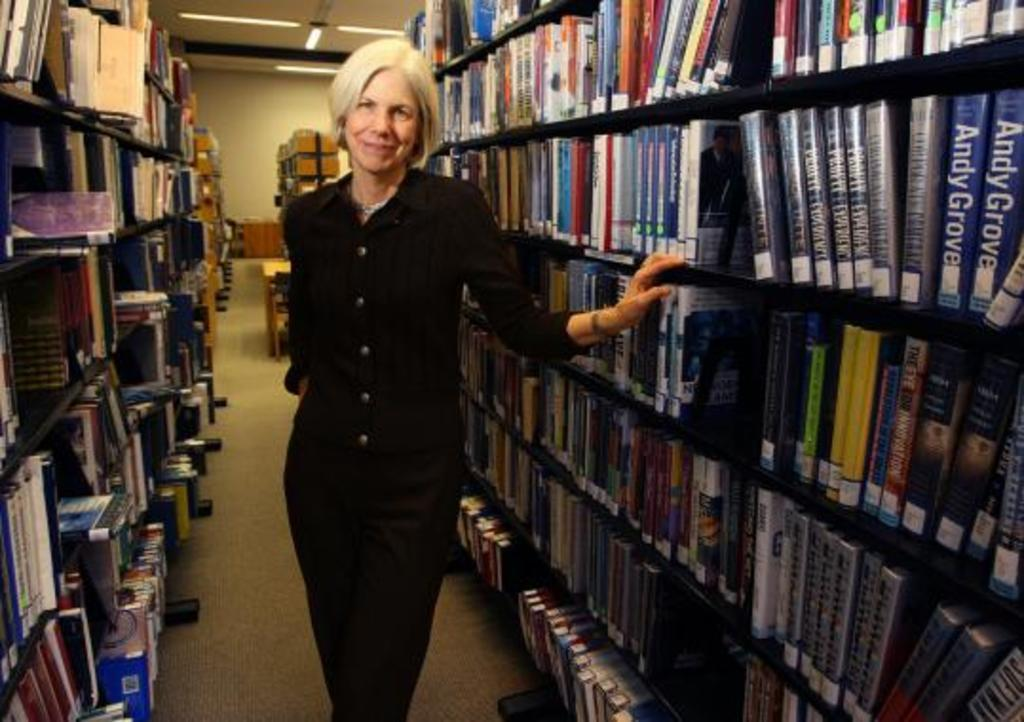<image>
Share a concise interpretation of the image provided. A smiling older woman stands in a library aisle near books with Andy Grove on the spine. 